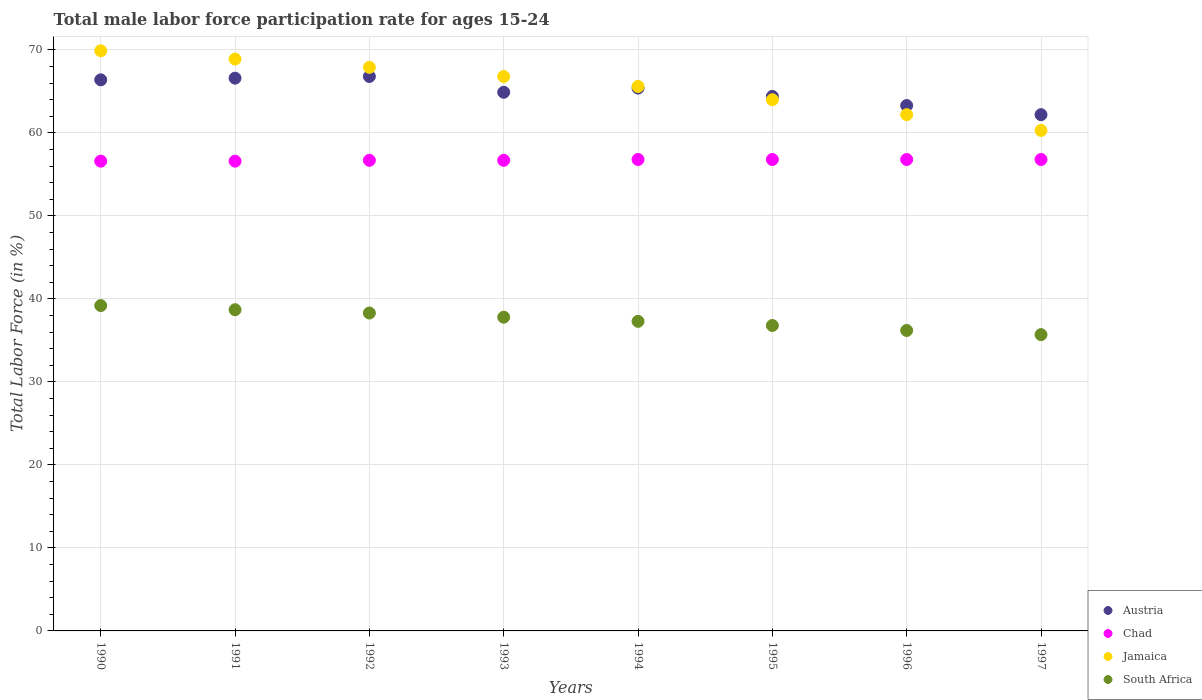How many different coloured dotlines are there?
Provide a succinct answer. 4. Is the number of dotlines equal to the number of legend labels?
Give a very brief answer. Yes. What is the male labor force participation rate in South Africa in 1996?
Make the answer very short. 36.2. Across all years, what is the maximum male labor force participation rate in Austria?
Offer a terse response. 66.8. Across all years, what is the minimum male labor force participation rate in Jamaica?
Ensure brevity in your answer.  60.3. What is the total male labor force participation rate in Austria in the graph?
Keep it short and to the point. 520. What is the difference between the male labor force participation rate in Chad in 1990 and that in 1996?
Provide a succinct answer. -0.2. What is the difference between the male labor force participation rate in Jamaica in 1993 and the male labor force participation rate in South Africa in 1994?
Offer a terse response. 29.5. What is the average male labor force participation rate in Austria per year?
Make the answer very short. 65. In the year 1997, what is the difference between the male labor force participation rate in South Africa and male labor force participation rate in Jamaica?
Provide a short and direct response. -24.6. What is the ratio of the male labor force participation rate in South Africa in 1991 to that in 1995?
Offer a very short reply. 1.05. Is the male labor force participation rate in South Africa in 1990 less than that in 1991?
Offer a very short reply. No. What is the difference between the highest and the lowest male labor force participation rate in Chad?
Offer a very short reply. 0.2. In how many years, is the male labor force participation rate in Chad greater than the average male labor force participation rate in Chad taken over all years?
Your response must be concise. 4. Is it the case that in every year, the sum of the male labor force participation rate in Jamaica and male labor force participation rate in Chad  is greater than the sum of male labor force participation rate in South Africa and male labor force participation rate in Austria?
Ensure brevity in your answer.  No. Is it the case that in every year, the sum of the male labor force participation rate in South Africa and male labor force participation rate in Austria  is greater than the male labor force participation rate in Chad?
Provide a short and direct response. Yes. Is the male labor force participation rate in Chad strictly less than the male labor force participation rate in Austria over the years?
Your answer should be compact. Yes. How many years are there in the graph?
Your response must be concise. 8. What is the difference between two consecutive major ticks on the Y-axis?
Offer a very short reply. 10. How many legend labels are there?
Provide a short and direct response. 4. How are the legend labels stacked?
Your answer should be very brief. Vertical. What is the title of the graph?
Your answer should be compact. Total male labor force participation rate for ages 15-24. What is the label or title of the X-axis?
Ensure brevity in your answer.  Years. What is the Total Labor Force (in %) in Austria in 1990?
Your answer should be compact. 66.4. What is the Total Labor Force (in %) in Chad in 1990?
Provide a succinct answer. 56.6. What is the Total Labor Force (in %) in Jamaica in 1990?
Your response must be concise. 69.9. What is the Total Labor Force (in %) of South Africa in 1990?
Your answer should be compact. 39.2. What is the Total Labor Force (in %) of Austria in 1991?
Ensure brevity in your answer.  66.6. What is the Total Labor Force (in %) in Chad in 1991?
Give a very brief answer. 56.6. What is the Total Labor Force (in %) of Jamaica in 1991?
Provide a short and direct response. 68.9. What is the Total Labor Force (in %) of South Africa in 1991?
Keep it short and to the point. 38.7. What is the Total Labor Force (in %) of Austria in 1992?
Keep it short and to the point. 66.8. What is the Total Labor Force (in %) of Chad in 1992?
Provide a short and direct response. 56.7. What is the Total Labor Force (in %) of Jamaica in 1992?
Your answer should be very brief. 67.9. What is the Total Labor Force (in %) of South Africa in 1992?
Give a very brief answer. 38.3. What is the Total Labor Force (in %) of Austria in 1993?
Offer a terse response. 64.9. What is the Total Labor Force (in %) of Chad in 1993?
Offer a very short reply. 56.7. What is the Total Labor Force (in %) in Jamaica in 1993?
Keep it short and to the point. 66.8. What is the Total Labor Force (in %) in South Africa in 1993?
Provide a succinct answer. 37.8. What is the Total Labor Force (in %) of Austria in 1994?
Ensure brevity in your answer.  65.4. What is the Total Labor Force (in %) in Chad in 1994?
Keep it short and to the point. 56.8. What is the Total Labor Force (in %) in Jamaica in 1994?
Provide a succinct answer. 65.6. What is the Total Labor Force (in %) of South Africa in 1994?
Your answer should be compact. 37.3. What is the Total Labor Force (in %) of Austria in 1995?
Your response must be concise. 64.4. What is the Total Labor Force (in %) of Chad in 1995?
Your answer should be very brief. 56.8. What is the Total Labor Force (in %) of Jamaica in 1995?
Make the answer very short. 64. What is the Total Labor Force (in %) of South Africa in 1995?
Provide a succinct answer. 36.8. What is the Total Labor Force (in %) of Austria in 1996?
Keep it short and to the point. 63.3. What is the Total Labor Force (in %) of Chad in 1996?
Offer a terse response. 56.8. What is the Total Labor Force (in %) of Jamaica in 1996?
Offer a very short reply. 62.2. What is the Total Labor Force (in %) in South Africa in 1996?
Offer a terse response. 36.2. What is the Total Labor Force (in %) of Austria in 1997?
Your answer should be very brief. 62.2. What is the Total Labor Force (in %) in Chad in 1997?
Offer a very short reply. 56.8. What is the Total Labor Force (in %) in Jamaica in 1997?
Your response must be concise. 60.3. What is the Total Labor Force (in %) in South Africa in 1997?
Give a very brief answer. 35.7. Across all years, what is the maximum Total Labor Force (in %) in Austria?
Give a very brief answer. 66.8. Across all years, what is the maximum Total Labor Force (in %) of Chad?
Your response must be concise. 56.8. Across all years, what is the maximum Total Labor Force (in %) of Jamaica?
Provide a short and direct response. 69.9. Across all years, what is the maximum Total Labor Force (in %) of South Africa?
Ensure brevity in your answer.  39.2. Across all years, what is the minimum Total Labor Force (in %) in Austria?
Give a very brief answer. 62.2. Across all years, what is the minimum Total Labor Force (in %) of Chad?
Your response must be concise. 56.6. Across all years, what is the minimum Total Labor Force (in %) of Jamaica?
Ensure brevity in your answer.  60.3. Across all years, what is the minimum Total Labor Force (in %) in South Africa?
Your response must be concise. 35.7. What is the total Total Labor Force (in %) in Austria in the graph?
Make the answer very short. 520. What is the total Total Labor Force (in %) in Chad in the graph?
Give a very brief answer. 453.8. What is the total Total Labor Force (in %) of Jamaica in the graph?
Make the answer very short. 525.6. What is the total Total Labor Force (in %) of South Africa in the graph?
Make the answer very short. 300. What is the difference between the Total Labor Force (in %) of Austria in 1990 and that in 1991?
Make the answer very short. -0.2. What is the difference between the Total Labor Force (in %) of Jamaica in 1990 and that in 1991?
Give a very brief answer. 1. What is the difference between the Total Labor Force (in %) in South Africa in 1990 and that in 1991?
Your response must be concise. 0.5. What is the difference between the Total Labor Force (in %) of Austria in 1990 and that in 1992?
Your response must be concise. -0.4. What is the difference between the Total Labor Force (in %) in Chad in 1990 and that in 1992?
Your response must be concise. -0.1. What is the difference between the Total Labor Force (in %) of South Africa in 1990 and that in 1992?
Your answer should be compact. 0.9. What is the difference between the Total Labor Force (in %) in Jamaica in 1990 and that in 1993?
Give a very brief answer. 3.1. What is the difference between the Total Labor Force (in %) in Chad in 1990 and that in 1994?
Offer a terse response. -0.2. What is the difference between the Total Labor Force (in %) in Jamaica in 1990 and that in 1994?
Provide a short and direct response. 4.3. What is the difference between the Total Labor Force (in %) of Chad in 1990 and that in 1995?
Ensure brevity in your answer.  -0.2. What is the difference between the Total Labor Force (in %) in South Africa in 1990 and that in 1995?
Your response must be concise. 2.4. What is the difference between the Total Labor Force (in %) in Jamaica in 1990 and that in 1996?
Ensure brevity in your answer.  7.7. What is the difference between the Total Labor Force (in %) of South Africa in 1990 and that in 1996?
Offer a very short reply. 3. What is the difference between the Total Labor Force (in %) of Austria in 1990 and that in 1997?
Your response must be concise. 4.2. What is the difference between the Total Labor Force (in %) in Chad in 1990 and that in 1997?
Your answer should be compact. -0.2. What is the difference between the Total Labor Force (in %) in Jamaica in 1990 and that in 1997?
Your answer should be compact. 9.6. What is the difference between the Total Labor Force (in %) in South Africa in 1990 and that in 1997?
Provide a succinct answer. 3.5. What is the difference between the Total Labor Force (in %) of Chad in 1991 and that in 1992?
Provide a succinct answer. -0.1. What is the difference between the Total Labor Force (in %) of Austria in 1991 and that in 1993?
Your answer should be compact. 1.7. What is the difference between the Total Labor Force (in %) of Chad in 1991 and that in 1993?
Your response must be concise. -0.1. What is the difference between the Total Labor Force (in %) of Jamaica in 1991 and that in 1993?
Ensure brevity in your answer.  2.1. What is the difference between the Total Labor Force (in %) of South Africa in 1991 and that in 1993?
Provide a succinct answer. 0.9. What is the difference between the Total Labor Force (in %) in Austria in 1991 and that in 1994?
Make the answer very short. 1.2. What is the difference between the Total Labor Force (in %) in Chad in 1991 and that in 1994?
Your response must be concise. -0.2. What is the difference between the Total Labor Force (in %) in Chad in 1991 and that in 1995?
Your answer should be compact. -0.2. What is the difference between the Total Labor Force (in %) of Chad in 1991 and that in 1996?
Give a very brief answer. -0.2. What is the difference between the Total Labor Force (in %) of Chad in 1991 and that in 1997?
Offer a very short reply. -0.2. What is the difference between the Total Labor Force (in %) in Jamaica in 1991 and that in 1997?
Offer a very short reply. 8.6. What is the difference between the Total Labor Force (in %) in South Africa in 1991 and that in 1997?
Provide a short and direct response. 3. What is the difference between the Total Labor Force (in %) in Austria in 1992 and that in 1993?
Your response must be concise. 1.9. What is the difference between the Total Labor Force (in %) in Chad in 1992 and that in 1993?
Offer a terse response. 0. What is the difference between the Total Labor Force (in %) of Jamaica in 1992 and that in 1993?
Your response must be concise. 1.1. What is the difference between the Total Labor Force (in %) of South Africa in 1992 and that in 1993?
Your answer should be compact. 0.5. What is the difference between the Total Labor Force (in %) of Chad in 1992 and that in 1994?
Keep it short and to the point. -0.1. What is the difference between the Total Labor Force (in %) of Chad in 1992 and that in 1995?
Ensure brevity in your answer.  -0.1. What is the difference between the Total Labor Force (in %) of Chad in 1992 and that in 1996?
Offer a very short reply. -0.1. What is the difference between the Total Labor Force (in %) of Chad in 1993 and that in 1994?
Offer a very short reply. -0.1. What is the difference between the Total Labor Force (in %) of South Africa in 1993 and that in 1994?
Offer a terse response. 0.5. What is the difference between the Total Labor Force (in %) in Austria in 1993 and that in 1995?
Offer a very short reply. 0.5. What is the difference between the Total Labor Force (in %) of Chad in 1993 and that in 1995?
Your answer should be very brief. -0.1. What is the difference between the Total Labor Force (in %) in Chad in 1993 and that in 1996?
Your response must be concise. -0.1. What is the difference between the Total Labor Force (in %) of Austria in 1993 and that in 1997?
Provide a succinct answer. 2.7. What is the difference between the Total Labor Force (in %) of Jamaica in 1993 and that in 1997?
Make the answer very short. 6.5. What is the difference between the Total Labor Force (in %) of Chad in 1994 and that in 1996?
Offer a terse response. 0. What is the difference between the Total Labor Force (in %) of South Africa in 1994 and that in 1996?
Keep it short and to the point. 1.1. What is the difference between the Total Labor Force (in %) of Austria in 1995 and that in 1996?
Your answer should be compact. 1.1. What is the difference between the Total Labor Force (in %) of Chad in 1995 and that in 1996?
Give a very brief answer. 0. What is the difference between the Total Labor Force (in %) in South Africa in 1995 and that in 1996?
Your answer should be compact. 0.6. What is the difference between the Total Labor Force (in %) of Jamaica in 1995 and that in 1997?
Your response must be concise. 3.7. What is the difference between the Total Labor Force (in %) of South Africa in 1995 and that in 1997?
Make the answer very short. 1.1. What is the difference between the Total Labor Force (in %) of South Africa in 1996 and that in 1997?
Give a very brief answer. 0.5. What is the difference between the Total Labor Force (in %) of Austria in 1990 and the Total Labor Force (in %) of Jamaica in 1991?
Provide a succinct answer. -2.5. What is the difference between the Total Labor Force (in %) in Austria in 1990 and the Total Labor Force (in %) in South Africa in 1991?
Offer a very short reply. 27.7. What is the difference between the Total Labor Force (in %) in Jamaica in 1990 and the Total Labor Force (in %) in South Africa in 1991?
Make the answer very short. 31.2. What is the difference between the Total Labor Force (in %) in Austria in 1990 and the Total Labor Force (in %) in Chad in 1992?
Ensure brevity in your answer.  9.7. What is the difference between the Total Labor Force (in %) of Austria in 1990 and the Total Labor Force (in %) of Jamaica in 1992?
Make the answer very short. -1.5. What is the difference between the Total Labor Force (in %) in Austria in 1990 and the Total Labor Force (in %) in South Africa in 1992?
Provide a succinct answer. 28.1. What is the difference between the Total Labor Force (in %) in Chad in 1990 and the Total Labor Force (in %) in Jamaica in 1992?
Ensure brevity in your answer.  -11.3. What is the difference between the Total Labor Force (in %) in Jamaica in 1990 and the Total Labor Force (in %) in South Africa in 1992?
Ensure brevity in your answer.  31.6. What is the difference between the Total Labor Force (in %) of Austria in 1990 and the Total Labor Force (in %) of Chad in 1993?
Your answer should be compact. 9.7. What is the difference between the Total Labor Force (in %) of Austria in 1990 and the Total Labor Force (in %) of Jamaica in 1993?
Offer a very short reply. -0.4. What is the difference between the Total Labor Force (in %) of Austria in 1990 and the Total Labor Force (in %) of South Africa in 1993?
Offer a terse response. 28.6. What is the difference between the Total Labor Force (in %) in Jamaica in 1990 and the Total Labor Force (in %) in South Africa in 1993?
Provide a succinct answer. 32.1. What is the difference between the Total Labor Force (in %) in Austria in 1990 and the Total Labor Force (in %) in Jamaica in 1994?
Your answer should be compact. 0.8. What is the difference between the Total Labor Force (in %) in Austria in 1990 and the Total Labor Force (in %) in South Africa in 1994?
Ensure brevity in your answer.  29.1. What is the difference between the Total Labor Force (in %) of Chad in 1990 and the Total Labor Force (in %) of South Africa in 1994?
Provide a short and direct response. 19.3. What is the difference between the Total Labor Force (in %) in Jamaica in 1990 and the Total Labor Force (in %) in South Africa in 1994?
Give a very brief answer. 32.6. What is the difference between the Total Labor Force (in %) in Austria in 1990 and the Total Labor Force (in %) in Chad in 1995?
Provide a succinct answer. 9.6. What is the difference between the Total Labor Force (in %) in Austria in 1990 and the Total Labor Force (in %) in Jamaica in 1995?
Keep it short and to the point. 2.4. What is the difference between the Total Labor Force (in %) of Austria in 1990 and the Total Labor Force (in %) of South Africa in 1995?
Give a very brief answer. 29.6. What is the difference between the Total Labor Force (in %) of Chad in 1990 and the Total Labor Force (in %) of South Africa in 1995?
Give a very brief answer. 19.8. What is the difference between the Total Labor Force (in %) of Jamaica in 1990 and the Total Labor Force (in %) of South Africa in 1995?
Your answer should be compact. 33.1. What is the difference between the Total Labor Force (in %) in Austria in 1990 and the Total Labor Force (in %) in Chad in 1996?
Your response must be concise. 9.6. What is the difference between the Total Labor Force (in %) in Austria in 1990 and the Total Labor Force (in %) in South Africa in 1996?
Offer a terse response. 30.2. What is the difference between the Total Labor Force (in %) of Chad in 1990 and the Total Labor Force (in %) of Jamaica in 1996?
Your answer should be compact. -5.6. What is the difference between the Total Labor Force (in %) in Chad in 1990 and the Total Labor Force (in %) in South Africa in 1996?
Your answer should be very brief. 20.4. What is the difference between the Total Labor Force (in %) of Jamaica in 1990 and the Total Labor Force (in %) of South Africa in 1996?
Give a very brief answer. 33.7. What is the difference between the Total Labor Force (in %) of Austria in 1990 and the Total Labor Force (in %) of South Africa in 1997?
Your answer should be compact. 30.7. What is the difference between the Total Labor Force (in %) of Chad in 1990 and the Total Labor Force (in %) of Jamaica in 1997?
Your answer should be compact. -3.7. What is the difference between the Total Labor Force (in %) in Chad in 1990 and the Total Labor Force (in %) in South Africa in 1997?
Your answer should be compact. 20.9. What is the difference between the Total Labor Force (in %) in Jamaica in 1990 and the Total Labor Force (in %) in South Africa in 1997?
Provide a short and direct response. 34.2. What is the difference between the Total Labor Force (in %) of Austria in 1991 and the Total Labor Force (in %) of Chad in 1992?
Ensure brevity in your answer.  9.9. What is the difference between the Total Labor Force (in %) of Austria in 1991 and the Total Labor Force (in %) of South Africa in 1992?
Give a very brief answer. 28.3. What is the difference between the Total Labor Force (in %) of Chad in 1991 and the Total Labor Force (in %) of South Africa in 1992?
Ensure brevity in your answer.  18.3. What is the difference between the Total Labor Force (in %) of Jamaica in 1991 and the Total Labor Force (in %) of South Africa in 1992?
Keep it short and to the point. 30.6. What is the difference between the Total Labor Force (in %) of Austria in 1991 and the Total Labor Force (in %) of Chad in 1993?
Ensure brevity in your answer.  9.9. What is the difference between the Total Labor Force (in %) in Austria in 1991 and the Total Labor Force (in %) in South Africa in 1993?
Ensure brevity in your answer.  28.8. What is the difference between the Total Labor Force (in %) of Chad in 1991 and the Total Labor Force (in %) of South Africa in 1993?
Offer a terse response. 18.8. What is the difference between the Total Labor Force (in %) in Jamaica in 1991 and the Total Labor Force (in %) in South Africa in 1993?
Provide a short and direct response. 31.1. What is the difference between the Total Labor Force (in %) in Austria in 1991 and the Total Labor Force (in %) in Chad in 1994?
Offer a terse response. 9.8. What is the difference between the Total Labor Force (in %) in Austria in 1991 and the Total Labor Force (in %) in South Africa in 1994?
Your response must be concise. 29.3. What is the difference between the Total Labor Force (in %) in Chad in 1991 and the Total Labor Force (in %) in South Africa in 1994?
Ensure brevity in your answer.  19.3. What is the difference between the Total Labor Force (in %) in Jamaica in 1991 and the Total Labor Force (in %) in South Africa in 1994?
Keep it short and to the point. 31.6. What is the difference between the Total Labor Force (in %) in Austria in 1991 and the Total Labor Force (in %) in Chad in 1995?
Give a very brief answer. 9.8. What is the difference between the Total Labor Force (in %) in Austria in 1991 and the Total Labor Force (in %) in South Africa in 1995?
Provide a succinct answer. 29.8. What is the difference between the Total Labor Force (in %) in Chad in 1991 and the Total Labor Force (in %) in Jamaica in 1995?
Your answer should be very brief. -7.4. What is the difference between the Total Labor Force (in %) in Chad in 1991 and the Total Labor Force (in %) in South Africa in 1995?
Keep it short and to the point. 19.8. What is the difference between the Total Labor Force (in %) in Jamaica in 1991 and the Total Labor Force (in %) in South Africa in 1995?
Your answer should be very brief. 32.1. What is the difference between the Total Labor Force (in %) in Austria in 1991 and the Total Labor Force (in %) in Chad in 1996?
Give a very brief answer. 9.8. What is the difference between the Total Labor Force (in %) of Austria in 1991 and the Total Labor Force (in %) of Jamaica in 1996?
Offer a terse response. 4.4. What is the difference between the Total Labor Force (in %) of Austria in 1991 and the Total Labor Force (in %) of South Africa in 1996?
Ensure brevity in your answer.  30.4. What is the difference between the Total Labor Force (in %) in Chad in 1991 and the Total Labor Force (in %) in South Africa in 1996?
Your response must be concise. 20.4. What is the difference between the Total Labor Force (in %) in Jamaica in 1991 and the Total Labor Force (in %) in South Africa in 1996?
Give a very brief answer. 32.7. What is the difference between the Total Labor Force (in %) in Austria in 1991 and the Total Labor Force (in %) in Jamaica in 1997?
Your answer should be very brief. 6.3. What is the difference between the Total Labor Force (in %) in Austria in 1991 and the Total Labor Force (in %) in South Africa in 1997?
Keep it short and to the point. 30.9. What is the difference between the Total Labor Force (in %) of Chad in 1991 and the Total Labor Force (in %) of Jamaica in 1997?
Offer a terse response. -3.7. What is the difference between the Total Labor Force (in %) in Chad in 1991 and the Total Labor Force (in %) in South Africa in 1997?
Provide a short and direct response. 20.9. What is the difference between the Total Labor Force (in %) of Jamaica in 1991 and the Total Labor Force (in %) of South Africa in 1997?
Provide a succinct answer. 33.2. What is the difference between the Total Labor Force (in %) in Austria in 1992 and the Total Labor Force (in %) in South Africa in 1993?
Make the answer very short. 29. What is the difference between the Total Labor Force (in %) of Jamaica in 1992 and the Total Labor Force (in %) of South Africa in 1993?
Ensure brevity in your answer.  30.1. What is the difference between the Total Labor Force (in %) of Austria in 1992 and the Total Labor Force (in %) of Jamaica in 1994?
Provide a short and direct response. 1.2. What is the difference between the Total Labor Force (in %) of Austria in 1992 and the Total Labor Force (in %) of South Africa in 1994?
Provide a succinct answer. 29.5. What is the difference between the Total Labor Force (in %) of Chad in 1992 and the Total Labor Force (in %) of South Africa in 1994?
Offer a terse response. 19.4. What is the difference between the Total Labor Force (in %) in Jamaica in 1992 and the Total Labor Force (in %) in South Africa in 1994?
Make the answer very short. 30.6. What is the difference between the Total Labor Force (in %) in Austria in 1992 and the Total Labor Force (in %) in Chad in 1995?
Keep it short and to the point. 10. What is the difference between the Total Labor Force (in %) of Austria in 1992 and the Total Labor Force (in %) of Jamaica in 1995?
Your answer should be very brief. 2.8. What is the difference between the Total Labor Force (in %) in Austria in 1992 and the Total Labor Force (in %) in South Africa in 1995?
Your response must be concise. 30. What is the difference between the Total Labor Force (in %) of Chad in 1992 and the Total Labor Force (in %) of South Africa in 1995?
Keep it short and to the point. 19.9. What is the difference between the Total Labor Force (in %) in Jamaica in 1992 and the Total Labor Force (in %) in South Africa in 1995?
Offer a very short reply. 31.1. What is the difference between the Total Labor Force (in %) of Austria in 1992 and the Total Labor Force (in %) of Chad in 1996?
Give a very brief answer. 10. What is the difference between the Total Labor Force (in %) in Austria in 1992 and the Total Labor Force (in %) in South Africa in 1996?
Provide a succinct answer. 30.6. What is the difference between the Total Labor Force (in %) of Chad in 1992 and the Total Labor Force (in %) of South Africa in 1996?
Make the answer very short. 20.5. What is the difference between the Total Labor Force (in %) of Jamaica in 1992 and the Total Labor Force (in %) of South Africa in 1996?
Provide a succinct answer. 31.7. What is the difference between the Total Labor Force (in %) of Austria in 1992 and the Total Labor Force (in %) of Chad in 1997?
Offer a terse response. 10. What is the difference between the Total Labor Force (in %) of Austria in 1992 and the Total Labor Force (in %) of Jamaica in 1997?
Give a very brief answer. 6.5. What is the difference between the Total Labor Force (in %) of Austria in 1992 and the Total Labor Force (in %) of South Africa in 1997?
Your answer should be very brief. 31.1. What is the difference between the Total Labor Force (in %) in Chad in 1992 and the Total Labor Force (in %) in South Africa in 1997?
Offer a terse response. 21. What is the difference between the Total Labor Force (in %) in Jamaica in 1992 and the Total Labor Force (in %) in South Africa in 1997?
Offer a very short reply. 32.2. What is the difference between the Total Labor Force (in %) of Austria in 1993 and the Total Labor Force (in %) of Jamaica in 1994?
Give a very brief answer. -0.7. What is the difference between the Total Labor Force (in %) in Austria in 1993 and the Total Labor Force (in %) in South Africa in 1994?
Your answer should be very brief. 27.6. What is the difference between the Total Labor Force (in %) in Chad in 1993 and the Total Labor Force (in %) in Jamaica in 1994?
Provide a short and direct response. -8.9. What is the difference between the Total Labor Force (in %) of Chad in 1993 and the Total Labor Force (in %) of South Africa in 1994?
Provide a short and direct response. 19.4. What is the difference between the Total Labor Force (in %) of Jamaica in 1993 and the Total Labor Force (in %) of South Africa in 1994?
Offer a very short reply. 29.5. What is the difference between the Total Labor Force (in %) in Austria in 1993 and the Total Labor Force (in %) in Jamaica in 1995?
Your answer should be compact. 0.9. What is the difference between the Total Labor Force (in %) of Austria in 1993 and the Total Labor Force (in %) of South Africa in 1995?
Your answer should be compact. 28.1. What is the difference between the Total Labor Force (in %) in Chad in 1993 and the Total Labor Force (in %) in Jamaica in 1995?
Provide a succinct answer. -7.3. What is the difference between the Total Labor Force (in %) in Chad in 1993 and the Total Labor Force (in %) in South Africa in 1995?
Provide a succinct answer. 19.9. What is the difference between the Total Labor Force (in %) in Jamaica in 1993 and the Total Labor Force (in %) in South Africa in 1995?
Offer a terse response. 30. What is the difference between the Total Labor Force (in %) of Austria in 1993 and the Total Labor Force (in %) of South Africa in 1996?
Ensure brevity in your answer.  28.7. What is the difference between the Total Labor Force (in %) of Chad in 1993 and the Total Labor Force (in %) of Jamaica in 1996?
Keep it short and to the point. -5.5. What is the difference between the Total Labor Force (in %) in Chad in 1993 and the Total Labor Force (in %) in South Africa in 1996?
Provide a succinct answer. 20.5. What is the difference between the Total Labor Force (in %) in Jamaica in 1993 and the Total Labor Force (in %) in South Africa in 1996?
Provide a succinct answer. 30.6. What is the difference between the Total Labor Force (in %) in Austria in 1993 and the Total Labor Force (in %) in Chad in 1997?
Give a very brief answer. 8.1. What is the difference between the Total Labor Force (in %) of Austria in 1993 and the Total Labor Force (in %) of Jamaica in 1997?
Keep it short and to the point. 4.6. What is the difference between the Total Labor Force (in %) in Austria in 1993 and the Total Labor Force (in %) in South Africa in 1997?
Make the answer very short. 29.2. What is the difference between the Total Labor Force (in %) in Chad in 1993 and the Total Labor Force (in %) in Jamaica in 1997?
Offer a very short reply. -3.6. What is the difference between the Total Labor Force (in %) in Jamaica in 1993 and the Total Labor Force (in %) in South Africa in 1997?
Provide a succinct answer. 31.1. What is the difference between the Total Labor Force (in %) in Austria in 1994 and the Total Labor Force (in %) in Chad in 1995?
Ensure brevity in your answer.  8.6. What is the difference between the Total Labor Force (in %) of Austria in 1994 and the Total Labor Force (in %) of South Africa in 1995?
Your answer should be very brief. 28.6. What is the difference between the Total Labor Force (in %) in Jamaica in 1994 and the Total Labor Force (in %) in South Africa in 1995?
Your answer should be very brief. 28.8. What is the difference between the Total Labor Force (in %) in Austria in 1994 and the Total Labor Force (in %) in Jamaica in 1996?
Make the answer very short. 3.2. What is the difference between the Total Labor Force (in %) in Austria in 1994 and the Total Labor Force (in %) in South Africa in 1996?
Provide a short and direct response. 29.2. What is the difference between the Total Labor Force (in %) of Chad in 1994 and the Total Labor Force (in %) of South Africa in 1996?
Your answer should be very brief. 20.6. What is the difference between the Total Labor Force (in %) in Jamaica in 1994 and the Total Labor Force (in %) in South Africa in 1996?
Make the answer very short. 29.4. What is the difference between the Total Labor Force (in %) of Austria in 1994 and the Total Labor Force (in %) of Jamaica in 1997?
Offer a very short reply. 5.1. What is the difference between the Total Labor Force (in %) in Austria in 1994 and the Total Labor Force (in %) in South Africa in 1997?
Your response must be concise. 29.7. What is the difference between the Total Labor Force (in %) of Chad in 1994 and the Total Labor Force (in %) of South Africa in 1997?
Your answer should be very brief. 21.1. What is the difference between the Total Labor Force (in %) of Jamaica in 1994 and the Total Labor Force (in %) of South Africa in 1997?
Ensure brevity in your answer.  29.9. What is the difference between the Total Labor Force (in %) of Austria in 1995 and the Total Labor Force (in %) of Jamaica in 1996?
Give a very brief answer. 2.2. What is the difference between the Total Labor Force (in %) in Austria in 1995 and the Total Labor Force (in %) in South Africa in 1996?
Your answer should be very brief. 28.2. What is the difference between the Total Labor Force (in %) in Chad in 1995 and the Total Labor Force (in %) in South Africa in 1996?
Keep it short and to the point. 20.6. What is the difference between the Total Labor Force (in %) of Jamaica in 1995 and the Total Labor Force (in %) of South Africa in 1996?
Ensure brevity in your answer.  27.8. What is the difference between the Total Labor Force (in %) of Austria in 1995 and the Total Labor Force (in %) of Chad in 1997?
Offer a terse response. 7.6. What is the difference between the Total Labor Force (in %) of Austria in 1995 and the Total Labor Force (in %) of South Africa in 1997?
Provide a succinct answer. 28.7. What is the difference between the Total Labor Force (in %) of Chad in 1995 and the Total Labor Force (in %) of South Africa in 1997?
Offer a terse response. 21.1. What is the difference between the Total Labor Force (in %) of Jamaica in 1995 and the Total Labor Force (in %) of South Africa in 1997?
Keep it short and to the point. 28.3. What is the difference between the Total Labor Force (in %) in Austria in 1996 and the Total Labor Force (in %) in South Africa in 1997?
Provide a succinct answer. 27.6. What is the difference between the Total Labor Force (in %) in Chad in 1996 and the Total Labor Force (in %) in Jamaica in 1997?
Offer a very short reply. -3.5. What is the difference between the Total Labor Force (in %) in Chad in 1996 and the Total Labor Force (in %) in South Africa in 1997?
Give a very brief answer. 21.1. What is the average Total Labor Force (in %) in Chad per year?
Provide a short and direct response. 56.73. What is the average Total Labor Force (in %) of Jamaica per year?
Ensure brevity in your answer.  65.7. What is the average Total Labor Force (in %) in South Africa per year?
Provide a short and direct response. 37.5. In the year 1990, what is the difference between the Total Labor Force (in %) in Austria and Total Labor Force (in %) in Jamaica?
Give a very brief answer. -3.5. In the year 1990, what is the difference between the Total Labor Force (in %) of Austria and Total Labor Force (in %) of South Africa?
Provide a short and direct response. 27.2. In the year 1990, what is the difference between the Total Labor Force (in %) in Chad and Total Labor Force (in %) in South Africa?
Provide a short and direct response. 17.4. In the year 1990, what is the difference between the Total Labor Force (in %) of Jamaica and Total Labor Force (in %) of South Africa?
Offer a terse response. 30.7. In the year 1991, what is the difference between the Total Labor Force (in %) of Austria and Total Labor Force (in %) of Jamaica?
Your answer should be very brief. -2.3. In the year 1991, what is the difference between the Total Labor Force (in %) in Austria and Total Labor Force (in %) in South Africa?
Provide a short and direct response. 27.9. In the year 1991, what is the difference between the Total Labor Force (in %) of Chad and Total Labor Force (in %) of Jamaica?
Offer a very short reply. -12.3. In the year 1991, what is the difference between the Total Labor Force (in %) of Chad and Total Labor Force (in %) of South Africa?
Keep it short and to the point. 17.9. In the year 1991, what is the difference between the Total Labor Force (in %) in Jamaica and Total Labor Force (in %) in South Africa?
Offer a very short reply. 30.2. In the year 1992, what is the difference between the Total Labor Force (in %) in Austria and Total Labor Force (in %) in Chad?
Provide a short and direct response. 10.1. In the year 1992, what is the difference between the Total Labor Force (in %) in Austria and Total Labor Force (in %) in South Africa?
Offer a very short reply. 28.5. In the year 1992, what is the difference between the Total Labor Force (in %) in Chad and Total Labor Force (in %) in Jamaica?
Your answer should be compact. -11.2. In the year 1992, what is the difference between the Total Labor Force (in %) of Chad and Total Labor Force (in %) of South Africa?
Your answer should be compact. 18.4. In the year 1992, what is the difference between the Total Labor Force (in %) of Jamaica and Total Labor Force (in %) of South Africa?
Make the answer very short. 29.6. In the year 1993, what is the difference between the Total Labor Force (in %) in Austria and Total Labor Force (in %) in South Africa?
Provide a succinct answer. 27.1. In the year 1993, what is the difference between the Total Labor Force (in %) of Chad and Total Labor Force (in %) of Jamaica?
Provide a short and direct response. -10.1. In the year 1993, what is the difference between the Total Labor Force (in %) in Jamaica and Total Labor Force (in %) in South Africa?
Keep it short and to the point. 29. In the year 1994, what is the difference between the Total Labor Force (in %) of Austria and Total Labor Force (in %) of South Africa?
Your answer should be very brief. 28.1. In the year 1994, what is the difference between the Total Labor Force (in %) in Jamaica and Total Labor Force (in %) in South Africa?
Offer a very short reply. 28.3. In the year 1995, what is the difference between the Total Labor Force (in %) of Austria and Total Labor Force (in %) of Chad?
Make the answer very short. 7.6. In the year 1995, what is the difference between the Total Labor Force (in %) in Austria and Total Labor Force (in %) in South Africa?
Offer a very short reply. 27.6. In the year 1995, what is the difference between the Total Labor Force (in %) of Chad and Total Labor Force (in %) of Jamaica?
Keep it short and to the point. -7.2. In the year 1995, what is the difference between the Total Labor Force (in %) in Chad and Total Labor Force (in %) in South Africa?
Offer a terse response. 20. In the year 1995, what is the difference between the Total Labor Force (in %) of Jamaica and Total Labor Force (in %) of South Africa?
Your answer should be compact. 27.2. In the year 1996, what is the difference between the Total Labor Force (in %) of Austria and Total Labor Force (in %) of Chad?
Your response must be concise. 6.5. In the year 1996, what is the difference between the Total Labor Force (in %) in Austria and Total Labor Force (in %) in South Africa?
Provide a succinct answer. 27.1. In the year 1996, what is the difference between the Total Labor Force (in %) in Chad and Total Labor Force (in %) in South Africa?
Provide a short and direct response. 20.6. In the year 1997, what is the difference between the Total Labor Force (in %) of Austria and Total Labor Force (in %) of Jamaica?
Make the answer very short. 1.9. In the year 1997, what is the difference between the Total Labor Force (in %) of Chad and Total Labor Force (in %) of South Africa?
Make the answer very short. 21.1. In the year 1997, what is the difference between the Total Labor Force (in %) of Jamaica and Total Labor Force (in %) of South Africa?
Your answer should be very brief. 24.6. What is the ratio of the Total Labor Force (in %) in Austria in 1990 to that in 1991?
Provide a short and direct response. 1. What is the ratio of the Total Labor Force (in %) in Chad in 1990 to that in 1991?
Give a very brief answer. 1. What is the ratio of the Total Labor Force (in %) in Jamaica in 1990 to that in 1991?
Provide a short and direct response. 1.01. What is the ratio of the Total Labor Force (in %) in South Africa in 1990 to that in 1991?
Your answer should be compact. 1.01. What is the ratio of the Total Labor Force (in %) in Jamaica in 1990 to that in 1992?
Provide a short and direct response. 1.03. What is the ratio of the Total Labor Force (in %) in South Africa in 1990 to that in 1992?
Offer a very short reply. 1.02. What is the ratio of the Total Labor Force (in %) in Austria in 1990 to that in 1993?
Ensure brevity in your answer.  1.02. What is the ratio of the Total Labor Force (in %) of Chad in 1990 to that in 1993?
Offer a very short reply. 1. What is the ratio of the Total Labor Force (in %) in Jamaica in 1990 to that in 1993?
Give a very brief answer. 1.05. What is the ratio of the Total Labor Force (in %) of South Africa in 1990 to that in 1993?
Give a very brief answer. 1.04. What is the ratio of the Total Labor Force (in %) of Austria in 1990 to that in 1994?
Make the answer very short. 1.02. What is the ratio of the Total Labor Force (in %) in Jamaica in 1990 to that in 1994?
Offer a terse response. 1.07. What is the ratio of the Total Labor Force (in %) in South Africa in 1990 to that in 1994?
Make the answer very short. 1.05. What is the ratio of the Total Labor Force (in %) of Austria in 1990 to that in 1995?
Provide a succinct answer. 1.03. What is the ratio of the Total Labor Force (in %) in Jamaica in 1990 to that in 1995?
Provide a short and direct response. 1.09. What is the ratio of the Total Labor Force (in %) in South Africa in 1990 to that in 1995?
Offer a very short reply. 1.07. What is the ratio of the Total Labor Force (in %) in Austria in 1990 to that in 1996?
Your answer should be compact. 1.05. What is the ratio of the Total Labor Force (in %) in Jamaica in 1990 to that in 1996?
Keep it short and to the point. 1.12. What is the ratio of the Total Labor Force (in %) in South Africa in 1990 to that in 1996?
Keep it short and to the point. 1.08. What is the ratio of the Total Labor Force (in %) in Austria in 1990 to that in 1997?
Give a very brief answer. 1.07. What is the ratio of the Total Labor Force (in %) in Chad in 1990 to that in 1997?
Give a very brief answer. 1. What is the ratio of the Total Labor Force (in %) in Jamaica in 1990 to that in 1997?
Make the answer very short. 1.16. What is the ratio of the Total Labor Force (in %) of South Africa in 1990 to that in 1997?
Make the answer very short. 1.1. What is the ratio of the Total Labor Force (in %) of Jamaica in 1991 to that in 1992?
Your answer should be very brief. 1.01. What is the ratio of the Total Labor Force (in %) of South Africa in 1991 to that in 1992?
Your answer should be compact. 1.01. What is the ratio of the Total Labor Force (in %) of Austria in 1991 to that in 1993?
Provide a short and direct response. 1.03. What is the ratio of the Total Labor Force (in %) of Chad in 1991 to that in 1993?
Your answer should be compact. 1. What is the ratio of the Total Labor Force (in %) of Jamaica in 1991 to that in 1993?
Make the answer very short. 1.03. What is the ratio of the Total Labor Force (in %) in South Africa in 1991 to that in 1993?
Keep it short and to the point. 1.02. What is the ratio of the Total Labor Force (in %) in Austria in 1991 to that in 1994?
Give a very brief answer. 1.02. What is the ratio of the Total Labor Force (in %) of Jamaica in 1991 to that in 1994?
Your answer should be compact. 1.05. What is the ratio of the Total Labor Force (in %) in South Africa in 1991 to that in 1994?
Keep it short and to the point. 1.04. What is the ratio of the Total Labor Force (in %) in Austria in 1991 to that in 1995?
Offer a very short reply. 1.03. What is the ratio of the Total Labor Force (in %) in Chad in 1991 to that in 1995?
Ensure brevity in your answer.  1. What is the ratio of the Total Labor Force (in %) in Jamaica in 1991 to that in 1995?
Your answer should be compact. 1.08. What is the ratio of the Total Labor Force (in %) in South Africa in 1991 to that in 1995?
Your answer should be compact. 1.05. What is the ratio of the Total Labor Force (in %) in Austria in 1991 to that in 1996?
Offer a terse response. 1.05. What is the ratio of the Total Labor Force (in %) in Chad in 1991 to that in 1996?
Provide a succinct answer. 1. What is the ratio of the Total Labor Force (in %) in Jamaica in 1991 to that in 1996?
Offer a terse response. 1.11. What is the ratio of the Total Labor Force (in %) of South Africa in 1991 to that in 1996?
Make the answer very short. 1.07. What is the ratio of the Total Labor Force (in %) of Austria in 1991 to that in 1997?
Provide a short and direct response. 1.07. What is the ratio of the Total Labor Force (in %) in Chad in 1991 to that in 1997?
Make the answer very short. 1. What is the ratio of the Total Labor Force (in %) of Jamaica in 1991 to that in 1997?
Ensure brevity in your answer.  1.14. What is the ratio of the Total Labor Force (in %) of South Africa in 1991 to that in 1997?
Provide a succinct answer. 1.08. What is the ratio of the Total Labor Force (in %) of Austria in 1992 to that in 1993?
Offer a very short reply. 1.03. What is the ratio of the Total Labor Force (in %) of Chad in 1992 to that in 1993?
Offer a very short reply. 1. What is the ratio of the Total Labor Force (in %) in Jamaica in 1992 to that in 1993?
Ensure brevity in your answer.  1.02. What is the ratio of the Total Labor Force (in %) of South Africa in 1992 to that in 1993?
Keep it short and to the point. 1.01. What is the ratio of the Total Labor Force (in %) of Austria in 1992 to that in 1994?
Provide a short and direct response. 1.02. What is the ratio of the Total Labor Force (in %) in Jamaica in 1992 to that in 1994?
Make the answer very short. 1.04. What is the ratio of the Total Labor Force (in %) in South Africa in 1992 to that in 1994?
Give a very brief answer. 1.03. What is the ratio of the Total Labor Force (in %) of Austria in 1992 to that in 1995?
Your answer should be very brief. 1.04. What is the ratio of the Total Labor Force (in %) of Chad in 1992 to that in 1995?
Your answer should be compact. 1. What is the ratio of the Total Labor Force (in %) of Jamaica in 1992 to that in 1995?
Your answer should be very brief. 1.06. What is the ratio of the Total Labor Force (in %) of South Africa in 1992 to that in 1995?
Ensure brevity in your answer.  1.04. What is the ratio of the Total Labor Force (in %) of Austria in 1992 to that in 1996?
Keep it short and to the point. 1.06. What is the ratio of the Total Labor Force (in %) in Chad in 1992 to that in 1996?
Offer a terse response. 1. What is the ratio of the Total Labor Force (in %) of Jamaica in 1992 to that in 1996?
Offer a very short reply. 1.09. What is the ratio of the Total Labor Force (in %) in South Africa in 1992 to that in 1996?
Make the answer very short. 1.06. What is the ratio of the Total Labor Force (in %) in Austria in 1992 to that in 1997?
Your answer should be very brief. 1.07. What is the ratio of the Total Labor Force (in %) in Chad in 1992 to that in 1997?
Your response must be concise. 1. What is the ratio of the Total Labor Force (in %) of Jamaica in 1992 to that in 1997?
Your answer should be very brief. 1.13. What is the ratio of the Total Labor Force (in %) in South Africa in 1992 to that in 1997?
Provide a succinct answer. 1.07. What is the ratio of the Total Labor Force (in %) of Austria in 1993 to that in 1994?
Give a very brief answer. 0.99. What is the ratio of the Total Labor Force (in %) in Chad in 1993 to that in 1994?
Keep it short and to the point. 1. What is the ratio of the Total Labor Force (in %) in Jamaica in 1993 to that in 1994?
Your answer should be very brief. 1.02. What is the ratio of the Total Labor Force (in %) in South Africa in 1993 to that in 1994?
Offer a very short reply. 1.01. What is the ratio of the Total Labor Force (in %) in Austria in 1993 to that in 1995?
Keep it short and to the point. 1.01. What is the ratio of the Total Labor Force (in %) of Chad in 1993 to that in 1995?
Your answer should be compact. 1. What is the ratio of the Total Labor Force (in %) of Jamaica in 1993 to that in 1995?
Ensure brevity in your answer.  1.04. What is the ratio of the Total Labor Force (in %) in South Africa in 1993 to that in 1995?
Offer a terse response. 1.03. What is the ratio of the Total Labor Force (in %) of Austria in 1993 to that in 1996?
Offer a terse response. 1.03. What is the ratio of the Total Labor Force (in %) of Chad in 1993 to that in 1996?
Your response must be concise. 1. What is the ratio of the Total Labor Force (in %) of Jamaica in 1993 to that in 1996?
Offer a terse response. 1.07. What is the ratio of the Total Labor Force (in %) in South Africa in 1993 to that in 1996?
Provide a succinct answer. 1.04. What is the ratio of the Total Labor Force (in %) of Austria in 1993 to that in 1997?
Keep it short and to the point. 1.04. What is the ratio of the Total Labor Force (in %) of Chad in 1993 to that in 1997?
Your response must be concise. 1. What is the ratio of the Total Labor Force (in %) of Jamaica in 1993 to that in 1997?
Offer a very short reply. 1.11. What is the ratio of the Total Labor Force (in %) in South Africa in 1993 to that in 1997?
Keep it short and to the point. 1.06. What is the ratio of the Total Labor Force (in %) of Austria in 1994 to that in 1995?
Provide a succinct answer. 1.02. What is the ratio of the Total Labor Force (in %) of South Africa in 1994 to that in 1995?
Your response must be concise. 1.01. What is the ratio of the Total Labor Force (in %) in Austria in 1994 to that in 1996?
Your answer should be very brief. 1.03. What is the ratio of the Total Labor Force (in %) in Chad in 1994 to that in 1996?
Keep it short and to the point. 1. What is the ratio of the Total Labor Force (in %) of Jamaica in 1994 to that in 1996?
Ensure brevity in your answer.  1.05. What is the ratio of the Total Labor Force (in %) of South Africa in 1994 to that in 1996?
Provide a short and direct response. 1.03. What is the ratio of the Total Labor Force (in %) in Austria in 1994 to that in 1997?
Your answer should be compact. 1.05. What is the ratio of the Total Labor Force (in %) of Jamaica in 1994 to that in 1997?
Provide a succinct answer. 1.09. What is the ratio of the Total Labor Force (in %) in South Africa in 1994 to that in 1997?
Offer a terse response. 1.04. What is the ratio of the Total Labor Force (in %) in Austria in 1995 to that in 1996?
Ensure brevity in your answer.  1.02. What is the ratio of the Total Labor Force (in %) in Chad in 1995 to that in 1996?
Make the answer very short. 1. What is the ratio of the Total Labor Force (in %) in Jamaica in 1995 to that in 1996?
Offer a terse response. 1.03. What is the ratio of the Total Labor Force (in %) of South Africa in 1995 to that in 1996?
Give a very brief answer. 1.02. What is the ratio of the Total Labor Force (in %) of Austria in 1995 to that in 1997?
Ensure brevity in your answer.  1.04. What is the ratio of the Total Labor Force (in %) of Jamaica in 1995 to that in 1997?
Offer a terse response. 1.06. What is the ratio of the Total Labor Force (in %) of South Africa in 1995 to that in 1997?
Provide a succinct answer. 1.03. What is the ratio of the Total Labor Force (in %) of Austria in 1996 to that in 1997?
Make the answer very short. 1.02. What is the ratio of the Total Labor Force (in %) of Jamaica in 1996 to that in 1997?
Ensure brevity in your answer.  1.03. What is the ratio of the Total Labor Force (in %) of South Africa in 1996 to that in 1997?
Make the answer very short. 1.01. What is the difference between the highest and the second highest Total Labor Force (in %) in Jamaica?
Keep it short and to the point. 1. What is the difference between the highest and the second highest Total Labor Force (in %) in South Africa?
Provide a succinct answer. 0.5. What is the difference between the highest and the lowest Total Labor Force (in %) in Austria?
Provide a succinct answer. 4.6. What is the difference between the highest and the lowest Total Labor Force (in %) of Chad?
Your answer should be compact. 0.2. What is the difference between the highest and the lowest Total Labor Force (in %) in South Africa?
Your response must be concise. 3.5. 